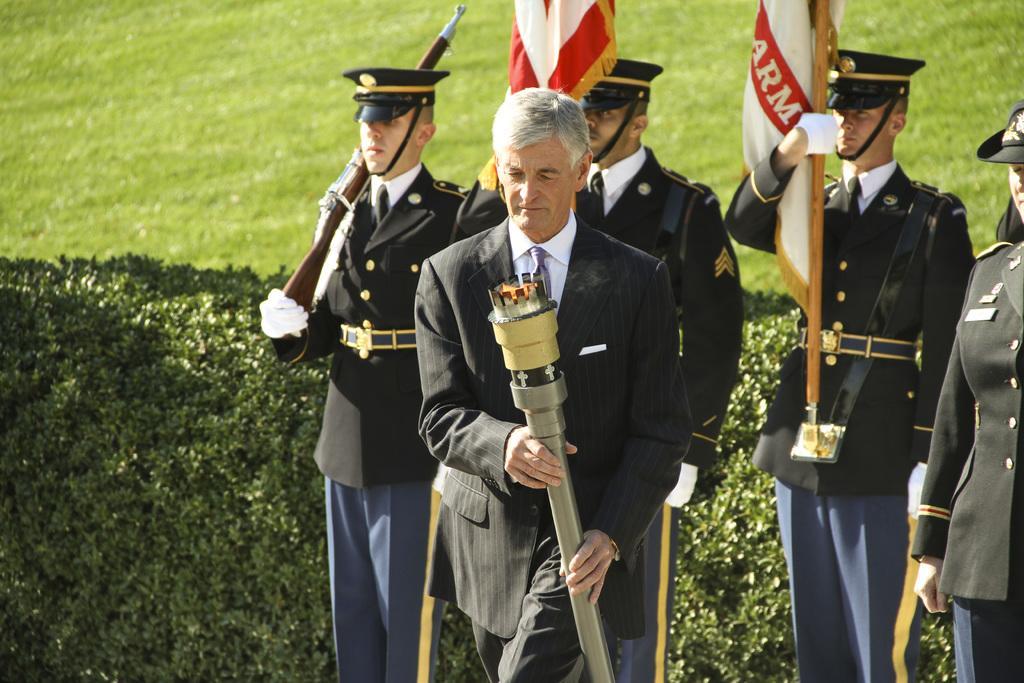How would you summarize this image in a sentence or two? In this image I can see a man is walking by holding the thing in his hands, he wore coat, tie, shirt. Behind him two men are standing by holding the flags in their hands, they wore caps. On the left side there are bushes. Here a man is standing by holding the weapon. 